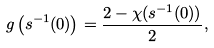Convert formula to latex. <formula><loc_0><loc_0><loc_500><loc_500>g \left ( s ^ { - 1 } ( 0 ) \right ) = \frac { 2 - \chi ( s ^ { - 1 } ( 0 ) ) } { 2 } ,</formula> 